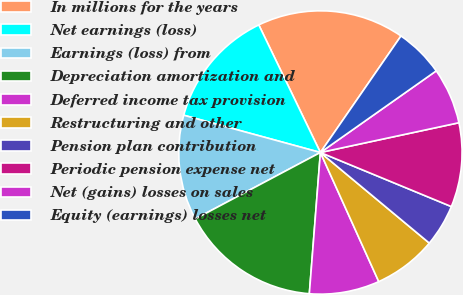<chart> <loc_0><loc_0><loc_500><loc_500><pie_chart><fcel>In millions for the years<fcel>Net earnings (loss)<fcel>Earnings (loss) from<fcel>Depreciation amortization and<fcel>Deferred income tax provision<fcel>Restructuring and other<fcel>Pension plan contribution<fcel>Periodic pension expense net<fcel>Net (gains) losses on sales<fcel>Equity (earnings) losses net<nl><fcel>16.79%<fcel>13.6%<fcel>12.0%<fcel>15.99%<fcel>8.0%<fcel>7.2%<fcel>4.81%<fcel>9.6%<fcel>6.4%<fcel>5.6%<nl></chart> 